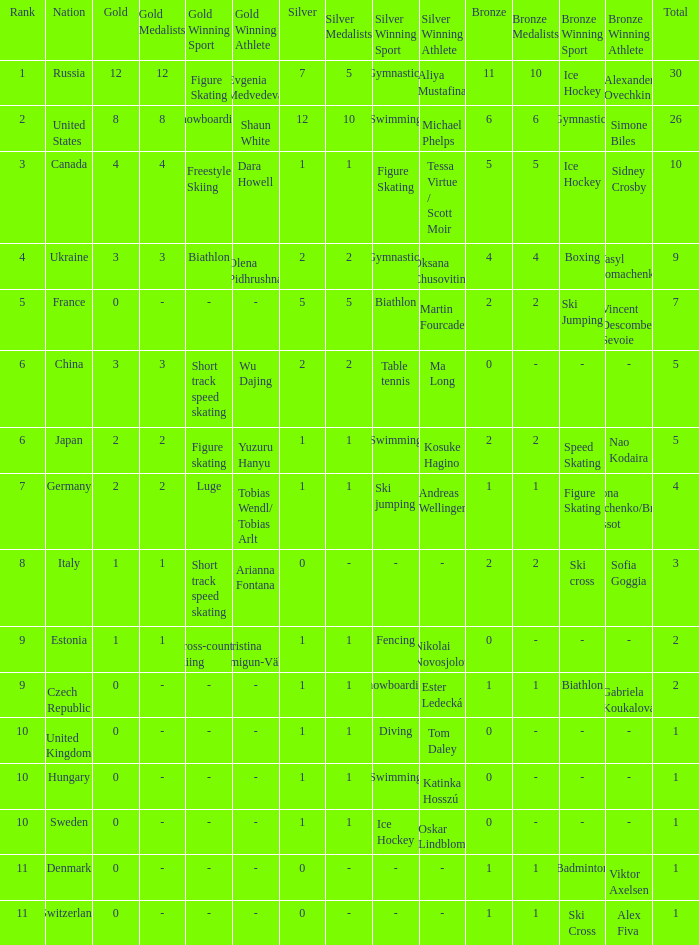What is the largest silver with Gold larger than 4, a Nation of united states, and a Total larger than 26? None. 